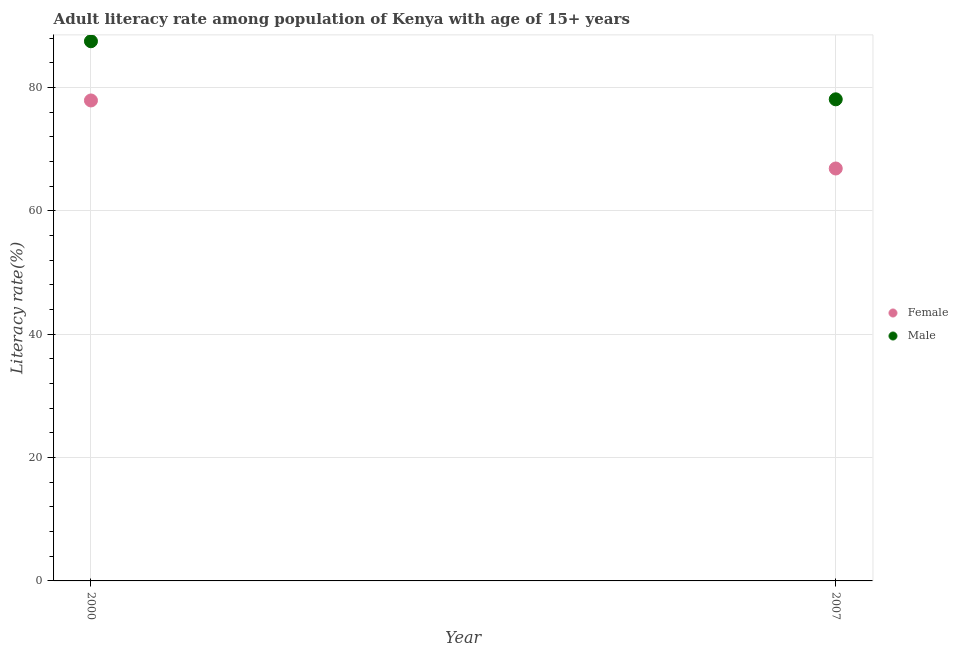Is the number of dotlines equal to the number of legend labels?
Your answer should be compact. Yes. What is the female adult literacy rate in 2007?
Ensure brevity in your answer.  66.86. Across all years, what is the maximum male adult literacy rate?
Keep it short and to the point. 87.49. Across all years, what is the minimum male adult literacy rate?
Your response must be concise. 78.08. In which year was the female adult literacy rate maximum?
Ensure brevity in your answer.  2000. What is the total male adult literacy rate in the graph?
Your answer should be very brief. 165.57. What is the difference between the male adult literacy rate in 2000 and that in 2007?
Your answer should be very brief. 9.42. What is the difference between the male adult literacy rate in 2007 and the female adult literacy rate in 2000?
Your response must be concise. 0.19. What is the average female adult literacy rate per year?
Make the answer very short. 72.38. In the year 2000, what is the difference between the male adult literacy rate and female adult literacy rate?
Ensure brevity in your answer.  9.6. What is the ratio of the male adult literacy rate in 2000 to that in 2007?
Give a very brief answer. 1.12. In how many years, is the female adult literacy rate greater than the average female adult literacy rate taken over all years?
Your answer should be very brief. 1. How many dotlines are there?
Offer a very short reply. 2. How many years are there in the graph?
Keep it short and to the point. 2. What is the difference between two consecutive major ticks on the Y-axis?
Ensure brevity in your answer.  20. Are the values on the major ticks of Y-axis written in scientific E-notation?
Your answer should be compact. No. Does the graph contain any zero values?
Your response must be concise. No. Does the graph contain grids?
Keep it short and to the point. Yes. Where does the legend appear in the graph?
Your answer should be compact. Center right. What is the title of the graph?
Make the answer very short. Adult literacy rate among population of Kenya with age of 15+ years. What is the label or title of the X-axis?
Offer a very short reply. Year. What is the label or title of the Y-axis?
Keep it short and to the point. Literacy rate(%). What is the Literacy rate(%) in Female in 2000?
Offer a terse response. 77.89. What is the Literacy rate(%) in Male in 2000?
Ensure brevity in your answer.  87.49. What is the Literacy rate(%) of Female in 2007?
Provide a succinct answer. 66.86. What is the Literacy rate(%) in Male in 2007?
Your response must be concise. 78.08. Across all years, what is the maximum Literacy rate(%) of Female?
Offer a very short reply. 77.89. Across all years, what is the maximum Literacy rate(%) of Male?
Your response must be concise. 87.49. Across all years, what is the minimum Literacy rate(%) of Female?
Offer a terse response. 66.86. Across all years, what is the minimum Literacy rate(%) in Male?
Give a very brief answer. 78.08. What is the total Literacy rate(%) in Female in the graph?
Provide a short and direct response. 144.76. What is the total Literacy rate(%) in Male in the graph?
Keep it short and to the point. 165.57. What is the difference between the Literacy rate(%) of Female in 2000 and that in 2007?
Offer a very short reply. 11.03. What is the difference between the Literacy rate(%) of Male in 2000 and that in 2007?
Ensure brevity in your answer.  9.42. What is the difference between the Literacy rate(%) in Female in 2000 and the Literacy rate(%) in Male in 2007?
Keep it short and to the point. -0.19. What is the average Literacy rate(%) of Female per year?
Offer a terse response. 72.38. What is the average Literacy rate(%) of Male per year?
Your response must be concise. 82.79. In the year 2000, what is the difference between the Literacy rate(%) in Female and Literacy rate(%) in Male?
Give a very brief answer. -9.6. In the year 2007, what is the difference between the Literacy rate(%) in Female and Literacy rate(%) in Male?
Your answer should be very brief. -11.22. What is the ratio of the Literacy rate(%) in Female in 2000 to that in 2007?
Provide a short and direct response. 1.17. What is the ratio of the Literacy rate(%) in Male in 2000 to that in 2007?
Your answer should be compact. 1.12. What is the difference between the highest and the second highest Literacy rate(%) in Female?
Keep it short and to the point. 11.03. What is the difference between the highest and the second highest Literacy rate(%) of Male?
Provide a short and direct response. 9.42. What is the difference between the highest and the lowest Literacy rate(%) of Female?
Your answer should be very brief. 11.03. What is the difference between the highest and the lowest Literacy rate(%) in Male?
Give a very brief answer. 9.42. 